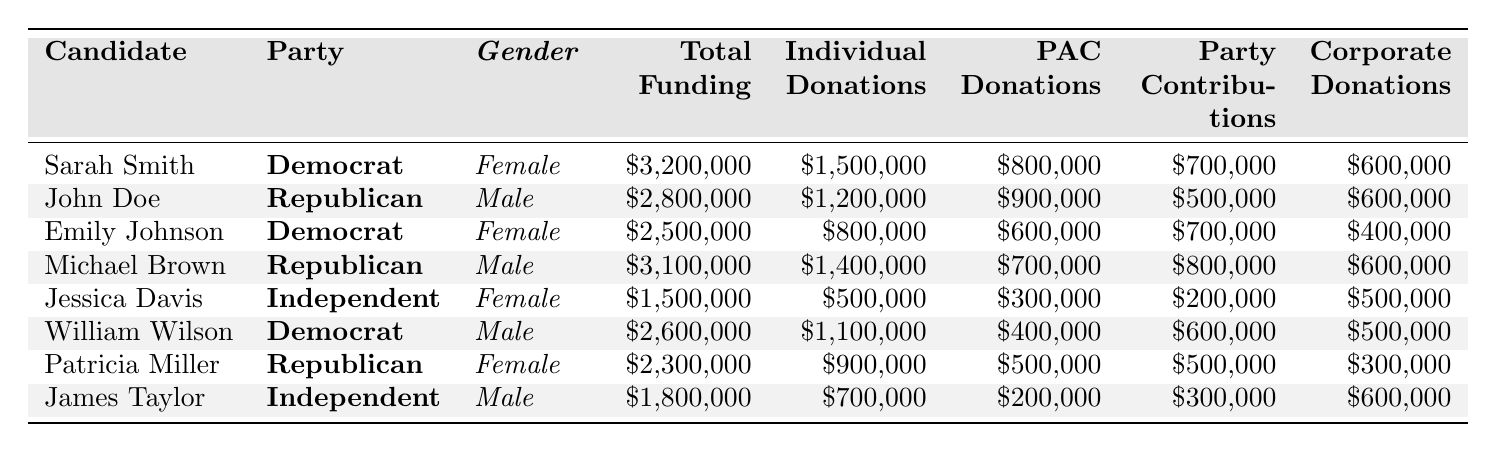What is the total funding received by Sarah Smith? Sarah Smith is listed in the table with a total funding amount of $3,200,000. This value can be found directly in the "Total Funding" column.
Answer: $3,200,000 Which candidate had the highest amount of individual donations? By examining the "Individual Donations" column, Sarah Smith has the highest individual donations amounting to $1,500,000. This is greater than any other candidate's individual donations listed in the table.
Answer: $1,500,000 Is Emily Johnson's funding greater than Michael Brown's? Emily Johnson's total funding is $2,500,000, while Michael Brown's is $3,100,000. Since $2,500,000 is less than $3,100,000, the statement is false.
Answer: No What is the average total funding for female candidates? The total funding for female candidates is calculated by summing Sarah Smith ($3,200,000), Emily Johnson ($2,500,000), Jessica Davis ($1,500,000), and Patricia Miller ($2,300,000), which equals $9,500,000. There are 4 female candidates, so the average funding is $9,500,000 ÷ 4 = $2,375,000.
Answer: $2,375,000 How much funding did male candidates receive in total? The funding amounts for male candidates are John Doe ($2,800,000), Michael Brown ($3,100,000), William Wilson ($2,600,000), and James Taylor ($1,800,000). Summing these figures gives $2,800,000 + $3,100,000 + $2,600,000 + $1,800,000 = $10,300,000.
Answer: $10,300,000 Who received the least funding among all candidates? In reviewing the "Total Funding" column, Jessica Davis has the least funding at $1,500,000, which is less than all other candidates' totals.
Answer: Jessica Davis What is the difference in total funding between the highest and lowest funded candidates? The highest funded candidate, Sarah Smith, has $3,200,000, and the lowest, Jessica Davis, has $1,500,000. The difference is $3,200,000 - $1,500,000 = $1,700,000.
Answer: $1,700,000 Are more funds collected through PAC donations than corporate donations by female candidates collectively? The total PAC donations for female candidates are $800,000 (Sarah Smith) + $600,000 (Emily Johnson) + $300,000 (Jessica Davis) + $500,000 (Patricia Miller) = $2,200,000. The total corporate donations for female candidates are $600,000 (Sarah Smith) + $400,000 (Emily Johnson) + $500,000 (Jessica Davis) + $300,000 (Patricia Miller) = $1,800,000. Since $2,200,000 is greater than $1,800,000, the answer is yes.
Answer: Yes What percentage of total funding for Emily Johnson comes from individual donations? Emily Johnson's total funding is $2,500,000, and her individual donations are $800,000. To find the percentage from individual donations, the calculation is ($800,000 ÷ $2,500,000) × 100 = 32%.
Answer: 32% 